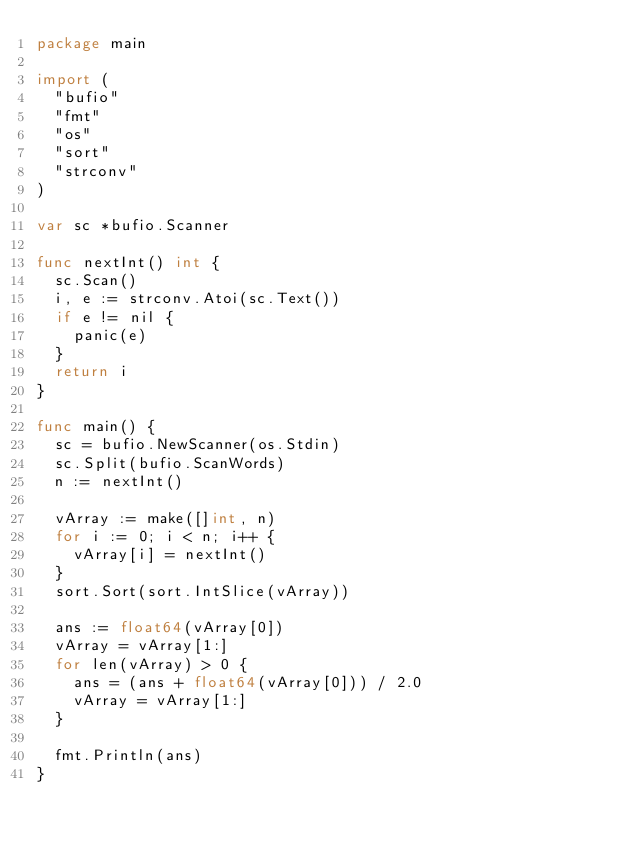<code> <loc_0><loc_0><loc_500><loc_500><_Go_>package main

import (
	"bufio"
	"fmt"
	"os"
	"sort"
	"strconv"
)

var sc *bufio.Scanner

func nextInt() int {
	sc.Scan()
	i, e := strconv.Atoi(sc.Text())
	if e != nil {
		panic(e)
	}
	return i
}

func main() {
	sc = bufio.NewScanner(os.Stdin)
	sc.Split(bufio.ScanWords)
	n := nextInt()

	vArray := make([]int, n)
	for i := 0; i < n; i++ {
		vArray[i] = nextInt()
	}
	sort.Sort(sort.IntSlice(vArray))

	ans := float64(vArray[0])
	vArray = vArray[1:]
	for len(vArray) > 0 {
		ans = (ans + float64(vArray[0])) / 2.0
		vArray = vArray[1:]
	}

	fmt.Println(ans)
}
</code> 